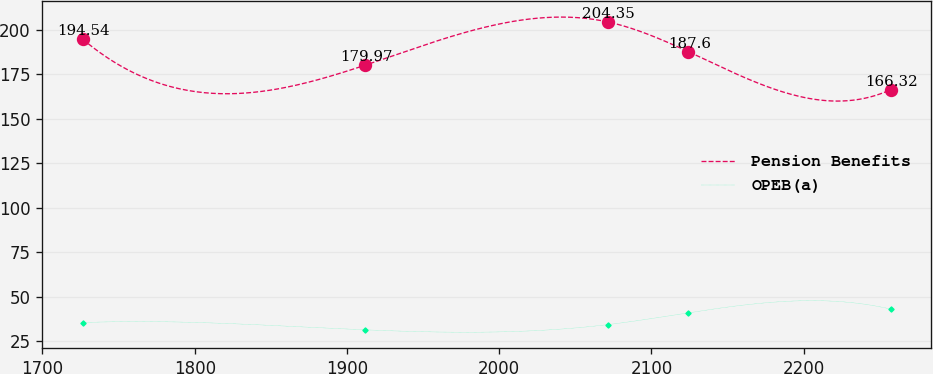<chart> <loc_0><loc_0><loc_500><loc_500><line_chart><ecel><fcel>Pension Benefits<fcel>OPEB(a)<nl><fcel>1726.53<fcel>194.54<fcel>35.35<nl><fcel>1911.86<fcel>179.97<fcel>31.29<nl><fcel>2071.15<fcel>204.35<fcel>34.19<nl><fcel>2124.24<fcel>187.6<fcel>40.84<nl><fcel>2257.38<fcel>166.32<fcel>42.91<nl></chart> 